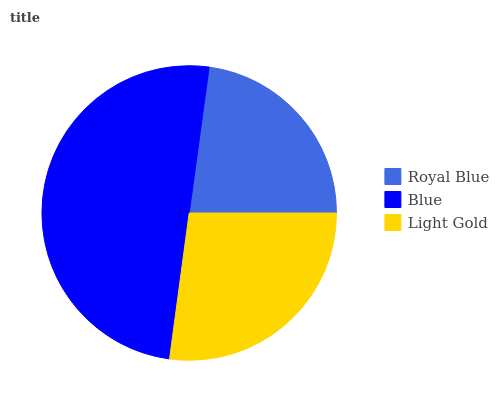Is Royal Blue the minimum?
Answer yes or no. Yes. Is Blue the maximum?
Answer yes or no. Yes. Is Light Gold the minimum?
Answer yes or no. No. Is Light Gold the maximum?
Answer yes or no. No. Is Blue greater than Light Gold?
Answer yes or no. Yes. Is Light Gold less than Blue?
Answer yes or no. Yes. Is Light Gold greater than Blue?
Answer yes or no. No. Is Blue less than Light Gold?
Answer yes or no. No. Is Light Gold the high median?
Answer yes or no. Yes. Is Light Gold the low median?
Answer yes or no. Yes. Is Blue the high median?
Answer yes or no. No. Is Blue the low median?
Answer yes or no. No. 